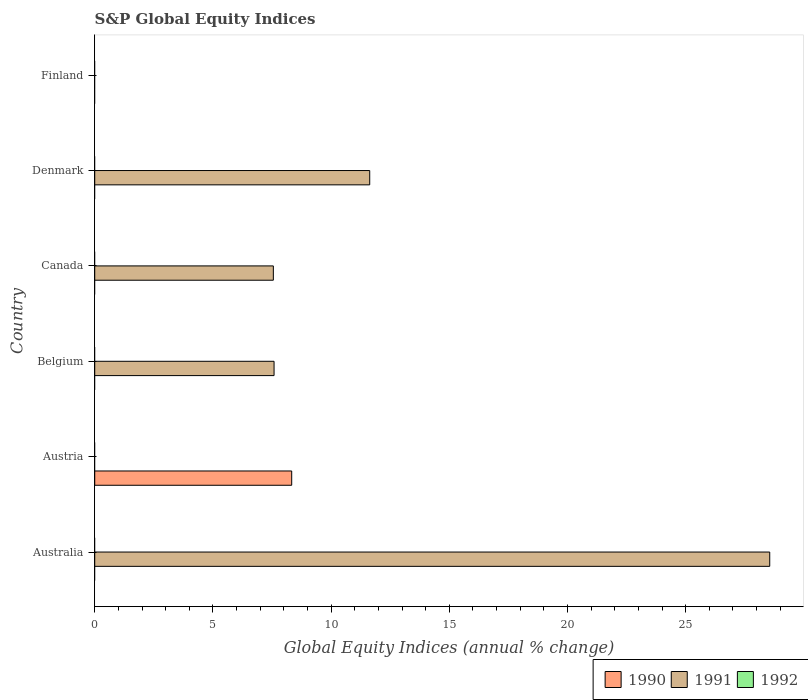Are the number of bars per tick equal to the number of legend labels?
Offer a very short reply. No. How many bars are there on the 3rd tick from the top?
Make the answer very short. 1. How many bars are there on the 5th tick from the bottom?
Provide a short and direct response. 1. In how many cases, is the number of bars for a given country not equal to the number of legend labels?
Your answer should be very brief. 6. What is the global equity indices in 1991 in Denmark?
Your response must be concise. 11.63. Across all countries, what is the maximum global equity indices in 1990?
Make the answer very short. 8.33. Across all countries, what is the minimum global equity indices in 1991?
Give a very brief answer. 0. In which country was the global equity indices in 1991 maximum?
Give a very brief answer. Australia. What is the total global equity indices in 1992 in the graph?
Provide a succinct answer. 0. What is the difference between the global equity indices in 1991 in Australia and that in Denmark?
Your answer should be compact. 16.92. What is the average global equity indices in 1991 per country?
Provide a succinct answer. 9.22. In how many countries, is the global equity indices in 1990 greater than 14 %?
Make the answer very short. 0. What is the ratio of the global equity indices in 1991 in Canada to that in Denmark?
Your response must be concise. 0.65. What is the difference between the highest and the second highest global equity indices in 1991?
Ensure brevity in your answer.  16.92. What is the difference between the highest and the lowest global equity indices in 1990?
Your answer should be compact. 8.33. In how many countries, is the global equity indices in 1992 greater than the average global equity indices in 1992 taken over all countries?
Provide a short and direct response. 0. Is it the case that in every country, the sum of the global equity indices in 1991 and global equity indices in 1990 is greater than the global equity indices in 1992?
Your answer should be compact. No. How many bars are there?
Provide a short and direct response. 5. Are the values on the major ticks of X-axis written in scientific E-notation?
Make the answer very short. No. Does the graph contain grids?
Offer a terse response. No. Where does the legend appear in the graph?
Offer a terse response. Bottom right. How many legend labels are there?
Provide a succinct answer. 3. What is the title of the graph?
Offer a terse response. S&P Global Equity Indices. What is the label or title of the X-axis?
Make the answer very short. Global Equity Indices (annual % change). What is the Global Equity Indices (annual % change) in 1991 in Australia?
Give a very brief answer. 28.56. What is the Global Equity Indices (annual % change) in 1992 in Australia?
Provide a short and direct response. 0. What is the Global Equity Indices (annual % change) in 1990 in Austria?
Your answer should be compact. 8.33. What is the Global Equity Indices (annual % change) of 1991 in Belgium?
Your answer should be very brief. 7.59. What is the Global Equity Indices (annual % change) in 1992 in Belgium?
Your response must be concise. 0. What is the Global Equity Indices (annual % change) in 1990 in Canada?
Your answer should be very brief. 0. What is the Global Equity Indices (annual % change) of 1991 in Canada?
Give a very brief answer. 7.56. What is the Global Equity Indices (annual % change) of 1992 in Canada?
Your answer should be compact. 0. What is the Global Equity Indices (annual % change) of 1990 in Denmark?
Provide a succinct answer. 0. What is the Global Equity Indices (annual % change) in 1991 in Denmark?
Ensure brevity in your answer.  11.63. What is the Global Equity Indices (annual % change) in 1992 in Denmark?
Give a very brief answer. 0. What is the Global Equity Indices (annual % change) in 1990 in Finland?
Offer a very short reply. 0. What is the Global Equity Indices (annual % change) in 1991 in Finland?
Offer a very short reply. 0. Across all countries, what is the maximum Global Equity Indices (annual % change) in 1990?
Your answer should be very brief. 8.33. Across all countries, what is the maximum Global Equity Indices (annual % change) in 1991?
Provide a succinct answer. 28.56. Across all countries, what is the minimum Global Equity Indices (annual % change) of 1991?
Ensure brevity in your answer.  0. What is the total Global Equity Indices (annual % change) in 1990 in the graph?
Make the answer very short. 8.33. What is the total Global Equity Indices (annual % change) of 1991 in the graph?
Offer a very short reply. 55.33. What is the total Global Equity Indices (annual % change) in 1992 in the graph?
Offer a very short reply. 0. What is the difference between the Global Equity Indices (annual % change) in 1991 in Australia and that in Belgium?
Provide a succinct answer. 20.97. What is the difference between the Global Equity Indices (annual % change) in 1991 in Australia and that in Canada?
Offer a terse response. 21. What is the difference between the Global Equity Indices (annual % change) in 1991 in Australia and that in Denmark?
Make the answer very short. 16.92. What is the difference between the Global Equity Indices (annual % change) in 1991 in Belgium and that in Canada?
Offer a very short reply. 0.03. What is the difference between the Global Equity Indices (annual % change) of 1991 in Belgium and that in Denmark?
Give a very brief answer. -4.05. What is the difference between the Global Equity Indices (annual % change) in 1991 in Canada and that in Denmark?
Offer a very short reply. -4.08. What is the difference between the Global Equity Indices (annual % change) of 1990 in Austria and the Global Equity Indices (annual % change) of 1991 in Belgium?
Your answer should be very brief. 0.75. What is the difference between the Global Equity Indices (annual % change) in 1990 in Austria and the Global Equity Indices (annual % change) in 1991 in Canada?
Your response must be concise. 0.78. What is the difference between the Global Equity Indices (annual % change) of 1990 in Austria and the Global Equity Indices (annual % change) of 1991 in Denmark?
Give a very brief answer. -3.3. What is the average Global Equity Indices (annual % change) of 1990 per country?
Offer a very short reply. 1.39. What is the average Global Equity Indices (annual % change) of 1991 per country?
Provide a short and direct response. 9.22. What is the average Global Equity Indices (annual % change) in 1992 per country?
Your answer should be compact. 0. What is the ratio of the Global Equity Indices (annual % change) of 1991 in Australia to that in Belgium?
Give a very brief answer. 3.76. What is the ratio of the Global Equity Indices (annual % change) in 1991 in Australia to that in Canada?
Provide a short and direct response. 3.78. What is the ratio of the Global Equity Indices (annual % change) of 1991 in Australia to that in Denmark?
Ensure brevity in your answer.  2.45. What is the ratio of the Global Equity Indices (annual % change) of 1991 in Belgium to that in Canada?
Your answer should be compact. 1. What is the ratio of the Global Equity Indices (annual % change) in 1991 in Belgium to that in Denmark?
Offer a very short reply. 0.65. What is the ratio of the Global Equity Indices (annual % change) of 1991 in Canada to that in Denmark?
Provide a short and direct response. 0.65. What is the difference between the highest and the second highest Global Equity Indices (annual % change) of 1991?
Provide a succinct answer. 16.92. What is the difference between the highest and the lowest Global Equity Indices (annual % change) in 1990?
Make the answer very short. 8.33. What is the difference between the highest and the lowest Global Equity Indices (annual % change) of 1991?
Your answer should be very brief. 28.56. 